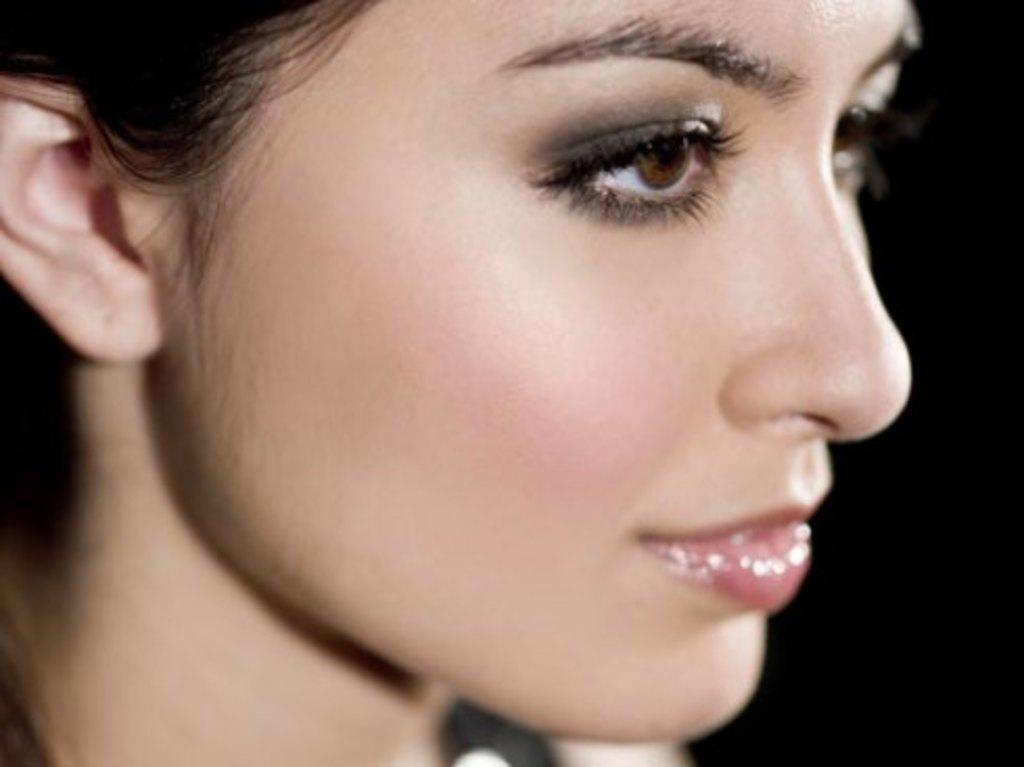Who is present in the image? There is a girl in the image. What type of liquid can be seen being divided at the airport in the image? There is no airport or liquid present in the image; it only features a girl. 